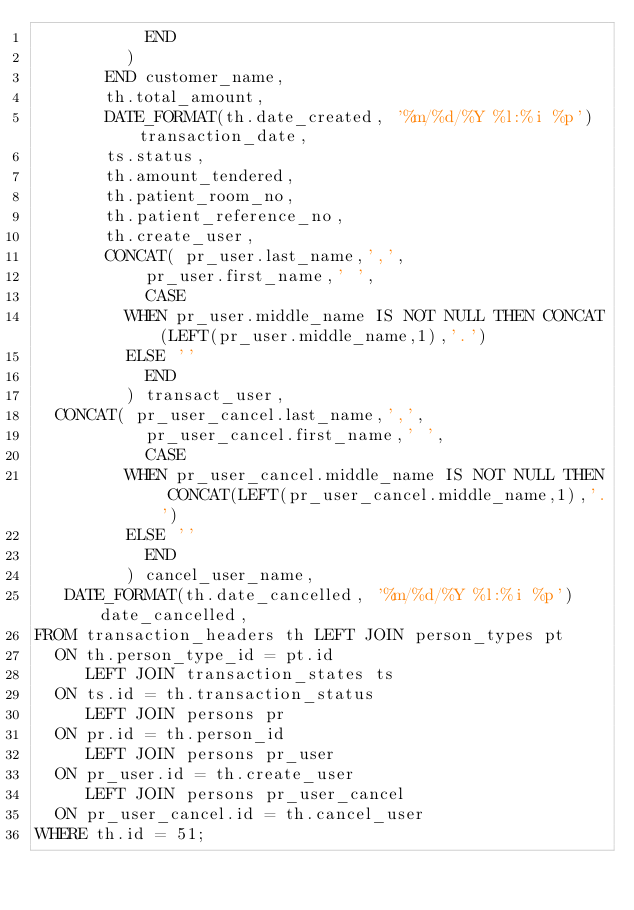<code> <loc_0><loc_0><loc_500><loc_500><_SQL_>		       END
	       )
       END customer_name,
       th.total_amount,
       DATE_FORMAT(th.date_created, '%m/%d/%Y %l:%i %p') transaction_date,
       ts.status,
       th.amount_tendered,
       th.patient_room_no,
       th.patient_reference_no,
       th.create_user,
       CONCAT( pr_user.last_name,',',
		       pr_user.first_name,' ',
		       CASE 
			   WHEN pr_user.middle_name IS NOT NULL THEN CONCAT(LEFT(pr_user.middle_name,1),'.')
			   ELSE ''
		       END
	       ) transact_user,
	CONCAT( pr_user_cancel.last_name,',',
		       pr_user_cancel.first_name,' ',
		       CASE 
			   WHEN pr_user_cancel.middle_name IS NOT NULL THEN CONCAT(LEFT(pr_user_cancel.middle_name,1),'.')
			   ELSE ''
		       END
	       ) cancel_user_name,
	 DATE_FORMAT(th.date_cancelled, '%m/%d/%Y %l:%i %p') date_cancelled,
FROM transaction_headers th LEFT JOIN person_types pt
	ON th.person_type_id = pt.id
     LEFT JOIN transaction_states ts
	ON ts.id = th.transaction_status
     LEFT JOIN persons pr
	ON pr.id = th.person_id
     LEFT JOIN persons pr_user
	ON pr_user.id = th.create_user
     LEFT JOIN persons pr_user_cancel
	ON pr_user_cancel.id = th.cancel_user
WHERE th.id = 51;
</code> 